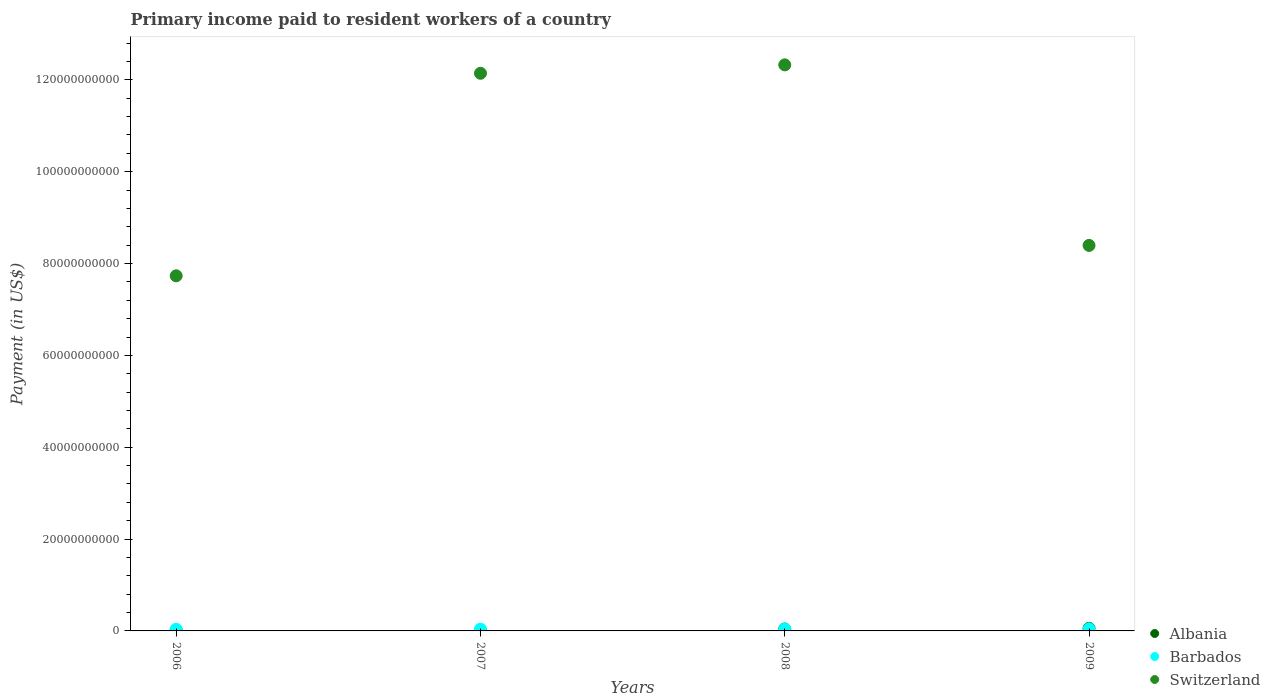What is the amount paid to workers in Barbados in 2008?
Offer a very short reply. 4.25e+08. Across all years, what is the maximum amount paid to workers in Albania?
Provide a short and direct response. 5.70e+08. Across all years, what is the minimum amount paid to workers in Barbados?
Provide a succinct answer. 3.67e+08. In which year was the amount paid to workers in Switzerland maximum?
Give a very brief answer. 2008. What is the total amount paid to workers in Albania in the graph?
Offer a very short reply. 1.14e+09. What is the difference between the amount paid to workers in Switzerland in 2006 and that in 2008?
Give a very brief answer. -4.59e+1. What is the difference between the amount paid to workers in Albania in 2009 and the amount paid to workers in Barbados in 2008?
Offer a very short reply. 1.45e+08. What is the average amount paid to workers in Switzerland per year?
Provide a short and direct response. 1.02e+11. In the year 2008, what is the difference between the amount paid to workers in Albania and amount paid to workers in Switzerland?
Your response must be concise. -1.23e+11. What is the ratio of the amount paid to workers in Albania in 2006 to that in 2009?
Give a very brief answer. 0.12. Is the amount paid to workers in Albania in 2006 less than that in 2007?
Make the answer very short. Yes. Is the difference between the amount paid to workers in Albania in 2006 and 2008 greater than the difference between the amount paid to workers in Switzerland in 2006 and 2008?
Your response must be concise. Yes. What is the difference between the highest and the second highest amount paid to workers in Switzerland?
Your response must be concise. 1.83e+09. What is the difference between the highest and the lowest amount paid to workers in Switzerland?
Provide a succinct answer. 4.59e+1. In how many years, is the amount paid to workers in Albania greater than the average amount paid to workers in Albania taken over all years?
Give a very brief answer. 2. Does the amount paid to workers in Barbados monotonically increase over the years?
Make the answer very short. Yes. Is the amount paid to workers in Barbados strictly less than the amount paid to workers in Albania over the years?
Make the answer very short. No. How many dotlines are there?
Your response must be concise. 3. How many years are there in the graph?
Make the answer very short. 4. What is the difference between two consecutive major ticks on the Y-axis?
Your answer should be very brief. 2.00e+1. Does the graph contain any zero values?
Keep it short and to the point. No. Where does the legend appear in the graph?
Provide a short and direct response. Bottom right. What is the title of the graph?
Your answer should be compact. Primary income paid to resident workers of a country. Does "Papua New Guinea" appear as one of the legend labels in the graph?
Your answer should be very brief. No. What is the label or title of the Y-axis?
Your answer should be compact. Payment (in US$). What is the Payment (in US$) of Albania in 2006?
Make the answer very short. 6.91e+07. What is the Payment (in US$) in Barbados in 2006?
Your response must be concise. 3.67e+08. What is the Payment (in US$) of Switzerland in 2006?
Your answer should be very brief. 7.73e+1. What is the Payment (in US$) in Albania in 2007?
Offer a very short reply. 8.51e+07. What is the Payment (in US$) of Barbados in 2007?
Provide a short and direct response. 3.88e+08. What is the Payment (in US$) in Switzerland in 2007?
Offer a very short reply. 1.21e+11. What is the Payment (in US$) of Albania in 2008?
Your response must be concise. 4.18e+08. What is the Payment (in US$) in Barbados in 2008?
Provide a short and direct response. 4.25e+08. What is the Payment (in US$) in Switzerland in 2008?
Keep it short and to the point. 1.23e+11. What is the Payment (in US$) of Albania in 2009?
Offer a terse response. 5.70e+08. What is the Payment (in US$) of Barbados in 2009?
Offer a very short reply. 4.64e+08. What is the Payment (in US$) of Switzerland in 2009?
Give a very brief answer. 8.40e+1. Across all years, what is the maximum Payment (in US$) in Albania?
Ensure brevity in your answer.  5.70e+08. Across all years, what is the maximum Payment (in US$) in Barbados?
Keep it short and to the point. 4.64e+08. Across all years, what is the maximum Payment (in US$) in Switzerland?
Your answer should be compact. 1.23e+11. Across all years, what is the minimum Payment (in US$) of Albania?
Ensure brevity in your answer.  6.91e+07. Across all years, what is the minimum Payment (in US$) of Barbados?
Provide a short and direct response. 3.67e+08. Across all years, what is the minimum Payment (in US$) in Switzerland?
Keep it short and to the point. 7.73e+1. What is the total Payment (in US$) in Albania in the graph?
Your response must be concise. 1.14e+09. What is the total Payment (in US$) in Barbados in the graph?
Ensure brevity in your answer.  1.64e+09. What is the total Payment (in US$) in Switzerland in the graph?
Make the answer very short. 4.06e+11. What is the difference between the Payment (in US$) in Albania in 2006 and that in 2007?
Give a very brief answer. -1.60e+07. What is the difference between the Payment (in US$) of Barbados in 2006 and that in 2007?
Provide a succinct answer. -2.06e+07. What is the difference between the Payment (in US$) in Switzerland in 2006 and that in 2007?
Provide a succinct answer. -4.41e+1. What is the difference between the Payment (in US$) of Albania in 2006 and that in 2008?
Your answer should be very brief. -3.49e+08. What is the difference between the Payment (in US$) of Barbados in 2006 and that in 2008?
Keep it short and to the point. -5.71e+07. What is the difference between the Payment (in US$) in Switzerland in 2006 and that in 2008?
Your answer should be very brief. -4.59e+1. What is the difference between the Payment (in US$) in Albania in 2006 and that in 2009?
Offer a terse response. -5.01e+08. What is the difference between the Payment (in US$) of Barbados in 2006 and that in 2009?
Give a very brief answer. -9.61e+07. What is the difference between the Payment (in US$) of Switzerland in 2006 and that in 2009?
Your answer should be very brief. -6.62e+09. What is the difference between the Payment (in US$) of Albania in 2007 and that in 2008?
Ensure brevity in your answer.  -3.33e+08. What is the difference between the Payment (in US$) of Barbados in 2007 and that in 2008?
Your answer should be compact. -3.65e+07. What is the difference between the Payment (in US$) of Switzerland in 2007 and that in 2008?
Your response must be concise. -1.83e+09. What is the difference between the Payment (in US$) of Albania in 2007 and that in 2009?
Offer a very short reply. -4.85e+08. What is the difference between the Payment (in US$) in Barbados in 2007 and that in 2009?
Your answer should be compact. -7.56e+07. What is the difference between the Payment (in US$) of Switzerland in 2007 and that in 2009?
Offer a very short reply. 3.75e+1. What is the difference between the Payment (in US$) in Albania in 2008 and that in 2009?
Provide a short and direct response. -1.52e+08. What is the difference between the Payment (in US$) in Barbados in 2008 and that in 2009?
Your answer should be compact. -3.90e+07. What is the difference between the Payment (in US$) in Switzerland in 2008 and that in 2009?
Provide a short and direct response. 3.93e+1. What is the difference between the Payment (in US$) in Albania in 2006 and the Payment (in US$) in Barbados in 2007?
Give a very brief answer. -3.19e+08. What is the difference between the Payment (in US$) in Albania in 2006 and the Payment (in US$) in Switzerland in 2007?
Offer a very short reply. -1.21e+11. What is the difference between the Payment (in US$) in Barbados in 2006 and the Payment (in US$) in Switzerland in 2007?
Provide a short and direct response. -1.21e+11. What is the difference between the Payment (in US$) in Albania in 2006 and the Payment (in US$) in Barbados in 2008?
Give a very brief answer. -3.55e+08. What is the difference between the Payment (in US$) in Albania in 2006 and the Payment (in US$) in Switzerland in 2008?
Give a very brief answer. -1.23e+11. What is the difference between the Payment (in US$) in Barbados in 2006 and the Payment (in US$) in Switzerland in 2008?
Ensure brevity in your answer.  -1.23e+11. What is the difference between the Payment (in US$) of Albania in 2006 and the Payment (in US$) of Barbados in 2009?
Offer a terse response. -3.94e+08. What is the difference between the Payment (in US$) in Albania in 2006 and the Payment (in US$) in Switzerland in 2009?
Provide a short and direct response. -8.39e+1. What is the difference between the Payment (in US$) of Barbados in 2006 and the Payment (in US$) of Switzerland in 2009?
Give a very brief answer. -8.36e+1. What is the difference between the Payment (in US$) in Albania in 2007 and the Payment (in US$) in Barbados in 2008?
Make the answer very short. -3.39e+08. What is the difference between the Payment (in US$) of Albania in 2007 and the Payment (in US$) of Switzerland in 2008?
Ensure brevity in your answer.  -1.23e+11. What is the difference between the Payment (in US$) in Barbados in 2007 and the Payment (in US$) in Switzerland in 2008?
Keep it short and to the point. -1.23e+11. What is the difference between the Payment (in US$) in Albania in 2007 and the Payment (in US$) in Barbados in 2009?
Give a very brief answer. -3.78e+08. What is the difference between the Payment (in US$) in Albania in 2007 and the Payment (in US$) in Switzerland in 2009?
Provide a short and direct response. -8.39e+1. What is the difference between the Payment (in US$) of Barbados in 2007 and the Payment (in US$) of Switzerland in 2009?
Provide a short and direct response. -8.36e+1. What is the difference between the Payment (in US$) of Albania in 2008 and the Payment (in US$) of Barbados in 2009?
Provide a succinct answer. -4.54e+07. What is the difference between the Payment (in US$) of Albania in 2008 and the Payment (in US$) of Switzerland in 2009?
Offer a terse response. -8.35e+1. What is the difference between the Payment (in US$) in Barbados in 2008 and the Payment (in US$) in Switzerland in 2009?
Ensure brevity in your answer.  -8.35e+1. What is the average Payment (in US$) in Albania per year?
Provide a succinct answer. 2.85e+08. What is the average Payment (in US$) in Barbados per year?
Offer a very short reply. 4.11e+08. What is the average Payment (in US$) in Switzerland per year?
Provide a succinct answer. 1.02e+11. In the year 2006, what is the difference between the Payment (in US$) of Albania and Payment (in US$) of Barbados?
Offer a very short reply. -2.98e+08. In the year 2006, what is the difference between the Payment (in US$) in Albania and Payment (in US$) in Switzerland?
Your answer should be very brief. -7.73e+1. In the year 2006, what is the difference between the Payment (in US$) in Barbados and Payment (in US$) in Switzerland?
Offer a very short reply. -7.70e+1. In the year 2007, what is the difference between the Payment (in US$) in Albania and Payment (in US$) in Barbados?
Provide a succinct answer. -3.03e+08. In the year 2007, what is the difference between the Payment (in US$) in Albania and Payment (in US$) in Switzerland?
Ensure brevity in your answer.  -1.21e+11. In the year 2007, what is the difference between the Payment (in US$) in Barbados and Payment (in US$) in Switzerland?
Your response must be concise. -1.21e+11. In the year 2008, what is the difference between the Payment (in US$) in Albania and Payment (in US$) in Barbados?
Provide a succinct answer. -6.39e+06. In the year 2008, what is the difference between the Payment (in US$) in Albania and Payment (in US$) in Switzerland?
Your response must be concise. -1.23e+11. In the year 2008, what is the difference between the Payment (in US$) of Barbados and Payment (in US$) of Switzerland?
Give a very brief answer. -1.23e+11. In the year 2009, what is the difference between the Payment (in US$) of Albania and Payment (in US$) of Barbados?
Offer a very short reply. 1.06e+08. In the year 2009, what is the difference between the Payment (in US$) of Albania and Payment (in US$) of Switzerland?
Ensure brevity in your answer.  -8.34e+1. In the year 2009, what is the difference between the Payment (in US$) in Barbados and Payment (in US$) in Switzerland?
Your response must be concise. -8.35e+1. What is the ratio of the Payment (in US$) of Albania in 2006 to that in 2007?
Give a very brief answer. 0.81. What is the ratio of the Payment (in US$) in Barbados in 2006 to that in 2007?
Make the answer very short. 0.95. What is the ratio of the Payment (in US$) of Switzerland in 2006 to that in 2007?
Offer a very short reply. 0.64. What is the ratio of the Payment (in US$) of Albania in 2006 to that in 2008?
Keep it short and to the point. 0.17. What is the ratio of the Payment (in US$) of Barbados in 2006 to that in 2008?
Offer a terse response. 0.87. What is the ratio of the Payment (in US$) in Switzerland in 2006 to that in 2008?
Give a very brief answer. 0.63. What is the ratio of the Payment (in US$) of Albania in 2006 to that in 2009?
Offer a terse response. 0.12. What is the ratio of the Payment (in US$) in Barbados in 2006 to that in 2009?
Provide a succinct answer. 0.79. What is the ratio of the Payment (in US$) of Switzerland in 2006 to that in 2009?
Make the answer very short. 0.92. What is the ratio of the Payment (in US$) in Albania in 2007 to that in 2008?
Offer a terse response. 0.2. What is the ratio of the Payment (in US$) in Barbados in 2007 to that in 2008?
Keep it short and to the point. 0.91. What is the ratio of the Payment (in US$) of Switzerland in 2007 to that in 2008?
Ensure brevity in your answer.  0.99. What is the ratio of the Payment (in US$) in Albania in 2007 to that in 2009?
Your answer should be very brief. 0.15. What is the ratio of the Payment (in US$) of Barbados in 2007 to that in 2009?
Your answer should be very brief. 0.84. What is the ratio of the Payment (in US$) of Switzerland in 2007 to that in 2009?
Make the answer very short. 1.45. What is the ratio of the Payment (in US$) of Albania in 2008 to that in 2009?
Offer a very short reply. 0.73. What is the ratio of the Payment (in US$) in Barbados in 2008 to that in 2009?
Your response must be concise. 0.92. What is the ratio of the Payment (in US$) of Switzerland in 2008 to that in 2009?
Provide a short and direct response. 1.47. What is the difference between the highest and the second highest Payment (in US$) in Albania?
Provide a succinct answer. 1.52e+08. What is the difference between the highest and the second highest Payment (in US$) in Barbados?
Your answer should be very brief. 3.90e+07. What is the difference between the highest and the second highest Payment (in US$) of Switzerland?
Keep it short and to the point. 1.83e+09. What is the difference between the highest and the lowest Payment (in US$) in Albania?
Make the answer very short. 5.01e+08. What is the difference between the highest and the lowest Payment (in US$) in Barbados?
Give a very brief answer. 9.61e+07. What is the difference between the highest and the lowest Payment (in US$) in Switzerland?
Keep it short and to the point. 4.59e+1. 